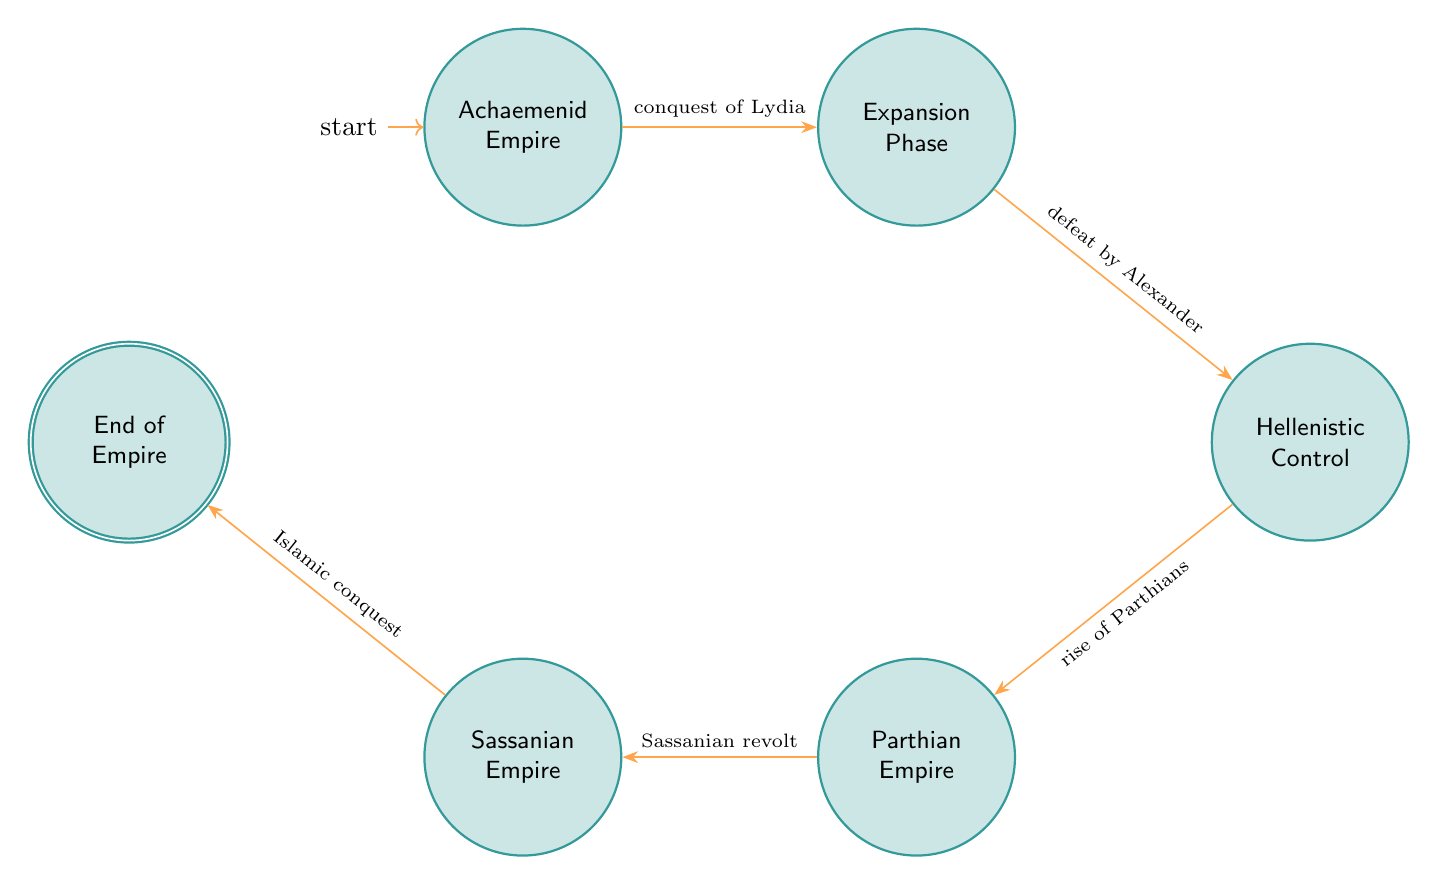What is the initial state in the diagram? The initial state is labeled "Achaemenid Empire," which indicates where the process begins in the flow of the diagram.
Answer: Achaemenid Empire How many states are represented in the diagram? The diagram contains six states: Achaemenid Empire, Expansion Phase, Hellenistic Control, Parthian Empire, Sassanian Empire, and End of Empire.
Answer: 6 Which event leads from the Expansion Phase to Hellenistic Control? The transition from Expansion Phase to Hellenistic Control is triggered by the event "defeat by Alexander," indicating the flow of historical events.
Answer: defeat by Alexander What type of state is the "End of Empire"? The "End of Empire" state is labeled as an accepting state, which usually signifies the termination of the process depicted in the diagram.
Answer: accepting What event transitions the Parthian Empire to the Sassanian Empire? The transition from the Parthian Empire to the Sassanian Empire occurs due to "Sassanian revolt," marking a significant change in control.
Answer: Sassanian revolt What was the first event in the evolution of the Persian Empire? The first event that sets off the evolution is the "conquest of Lydia," which leads to the expansion of the Achaemenid Empire.
Answer: conquest of Lydia Which state follows Hellenistic Control in the diagram? After Hellenistic Control, the diagram transitions to the Parthian Empire, highlighting the rise of a new ruling dynasty.
Answer: Parthian Empire How does one move from the Sassanian Empire to the End of Empire? The transition from the Sassanian Empire to the End of Empire is marked by the event "Islamic conquest," indicating the historical conquest that led to the empire's fall.
Answer: Islamic conquest 